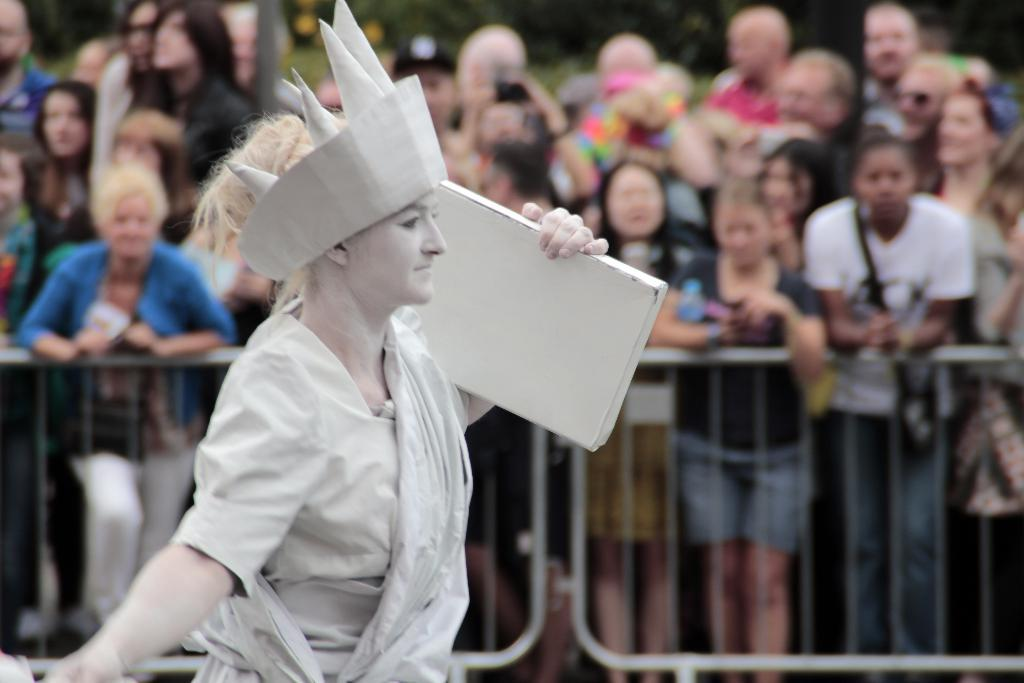How many people are in the image? There is a group of people in the image. Can you describe the woman in the middle of the image? A woman is present in the middle of the image. What is the woman holding in the image? The woman is holding an object. What can be seen in the background of the image? There is a fence visible in the background of the image. What type of comfort can be seen in the image? There is no specific comfort item present in the image. How many baseballs are visible in the image? There is no mention of baseballs or any sports equipment in the image. 